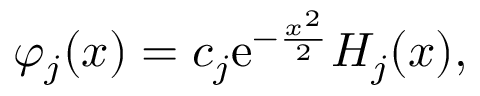<formula> <loc_0><loc_0><loc_500><loc_500>\varphi _ { j } ( x ) = c _ { j } e ^ { - \frac { x ^ { 2 } } { 2 } } H _ { j } ( x ) ,</formula> 